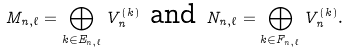<formula> <loc_0><loc_0><loc_500><loc_500>M _ { n , \ell } = \bigoplus _ { k \in E _ { n , \ell } } V _ { n } ^ { ( k ) } \text { and } N _ { n , \ell } = \bigoplus _ { k \in F _ { n , \ell } } V _ { n } ^ { ( k ) } .</formula> 